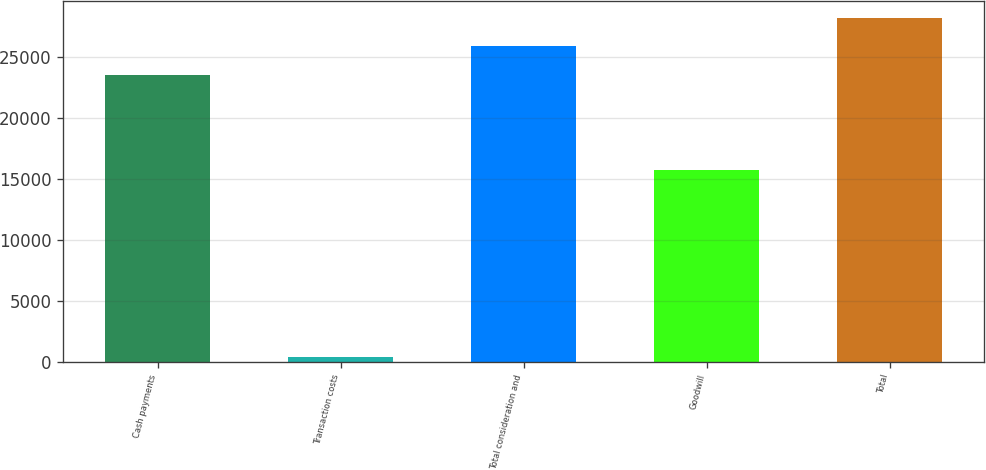Convert chart. <chart><loc_0><loc_0><loc_500><loc_500><bar_chart><fcel>Cash payments<fcel>Transaction costs<fcel>Total consideration and<fcel>Goodwill<fcel>Total<nl><fcel>23573<fcel>375<fcel>25901.5<fcel>15738<fcel>28230<nl></chart> 